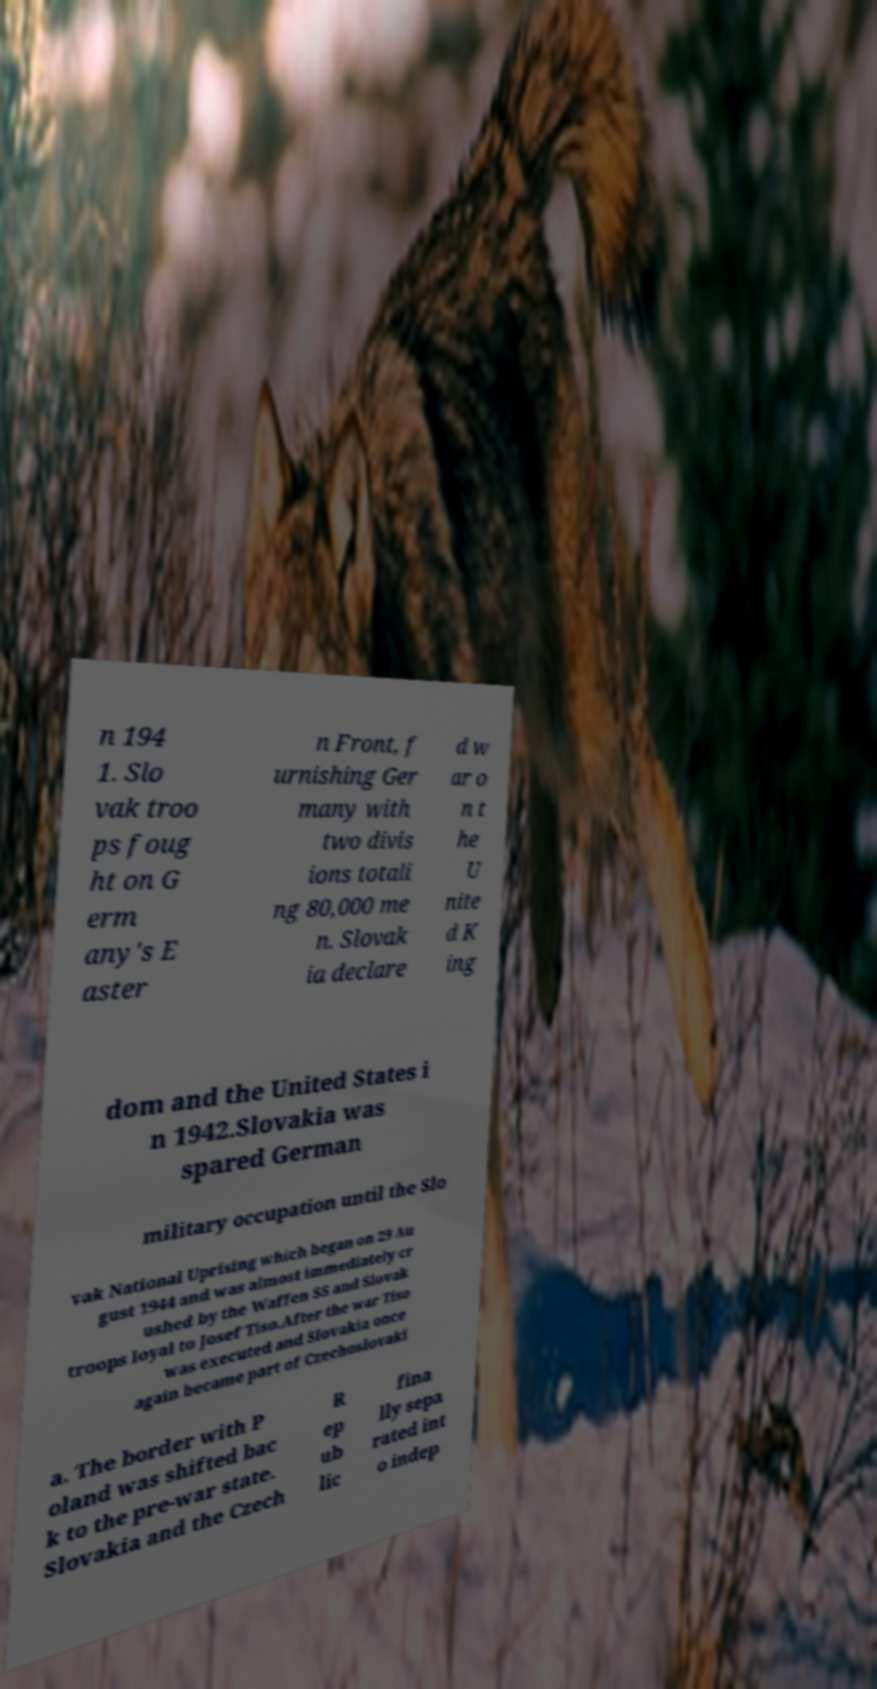Could you assist in decoding the text presented in this image and type it out clearly? n 194 1. Slo vak troo ps foug ht on G erm any's E aster n Front, f urnishing Ger many with two divis ions totali ng 80,000 me n. Slovak ia declare d w ar o n t he U nite d K ing dom and the United States i n 1942.Slovakia was spared German military occupation until the Slo vak National Uprising which began on 29 Au gust 1944 and was almost immediately cr ushed by the Waffen SS and Slovak troops loyal to Josef Tiso.After the war Tiso was executed and Slovakia once again became part of Czechoslovaki a. The border with P oland was shifted bac k to the pre-war state. Slovakia and the Czech R ep ub lic fina lly sepa rated int o indep 